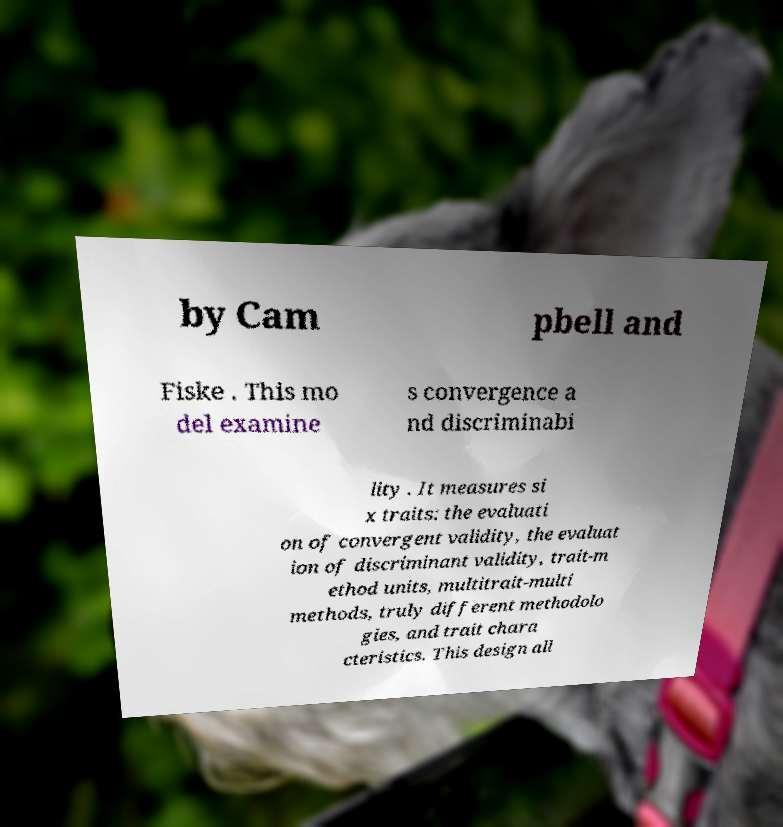Could you assist in decoding the text presented in this image and type it out clearly? by Cam pbell and Fiske . This mo del examine s convergence a nd discriminabi lity . It measures si x traits: the evaluati on of convergent validity, the evaluat ion of discriminant validity, trait-m ethod units, multitrait-multi methods, truly different methodolo gies, and trait chara cteristics. This design all 